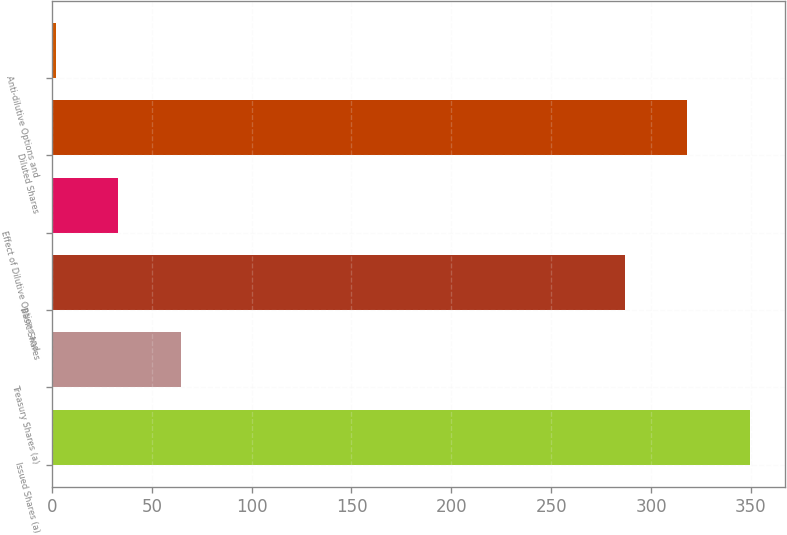Convert chart. <chart><loc_0><loc_0><loc_500><loc_500><bar_chart><fcel>Issued Shares (a)<fcel>Treasury Shares (a)<fcel>Basic Shares<fcel>Effect of Dilutive Options and<fcel>Diluted Shares<fcel>Anti-dilutive Options and<nl><fcel>349.4<fcel>64.4<fcel>287<fcel>33.2<fcel>318.2<fcel>2<nl></chart> 